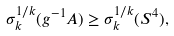Convert formula to latex. <formula><loc_0><loc_0><loc_500><loc_500>\sigma _ { k } ^ { 1 / k } ( g ^ { - 1 } A ) \geq \sigma _ { k } ^ { 1 / k } ( S ^ { 4 } ) ,</formula> 